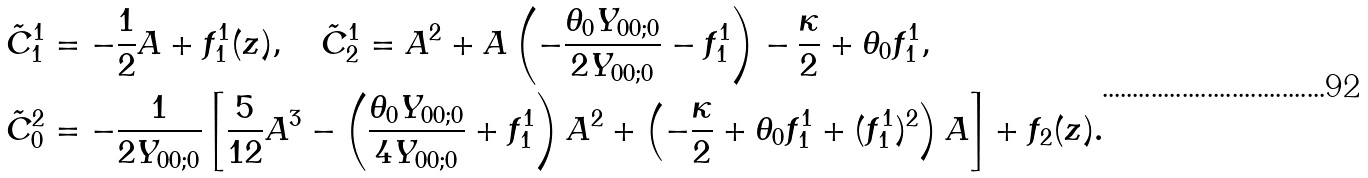<formula> <loc_0><loc_0><loc_500><loc_500>\tilde { C } _ { 1 } ^ { 1 } & = - \frac { 1 } { 2 } A + f _ { 1 } ^ { 1 } ( z ) , \quad \tilde { C } _ { 2 } ^ { 1 } = A ^ { 2 } + A \left ( - \frac { \theta _ { 0 } Y _ { 0 0 ; 0 } } { 2 Y _ { 0 0 ; 0 } } - f _ { 1 } ^ { 1 } \right ) - \frac { \kappa } { 2 } + \theta _ { 0 } f _ { 1 } ^ { 1 } , \\ \tilde { C } _ { 0 } ^ { 2 } & = - \frac { 1 } { 2 Y _ { 0 0 ; 0 } } \left [ \frac { 5 } { 1 2 } A ^ { 3 } - \left ( \frac { \theta _ { 0 } Y _ { 0 0 ; 0 } } { 4 Y _ { 0 0 ; 0 } } + f _ { 1 } ^ { 1 } \right ) A ^ { 2 } + \left ( - \frac { \kappa } { 2 } + \theta _ { 0 } f _ { 1 } ^ { 1 } + ( f _ { 1 } ^ { 1 } ) ^ { 2 } \right ) A \right ] + f _ { 2 } ( z ) .</formula> 